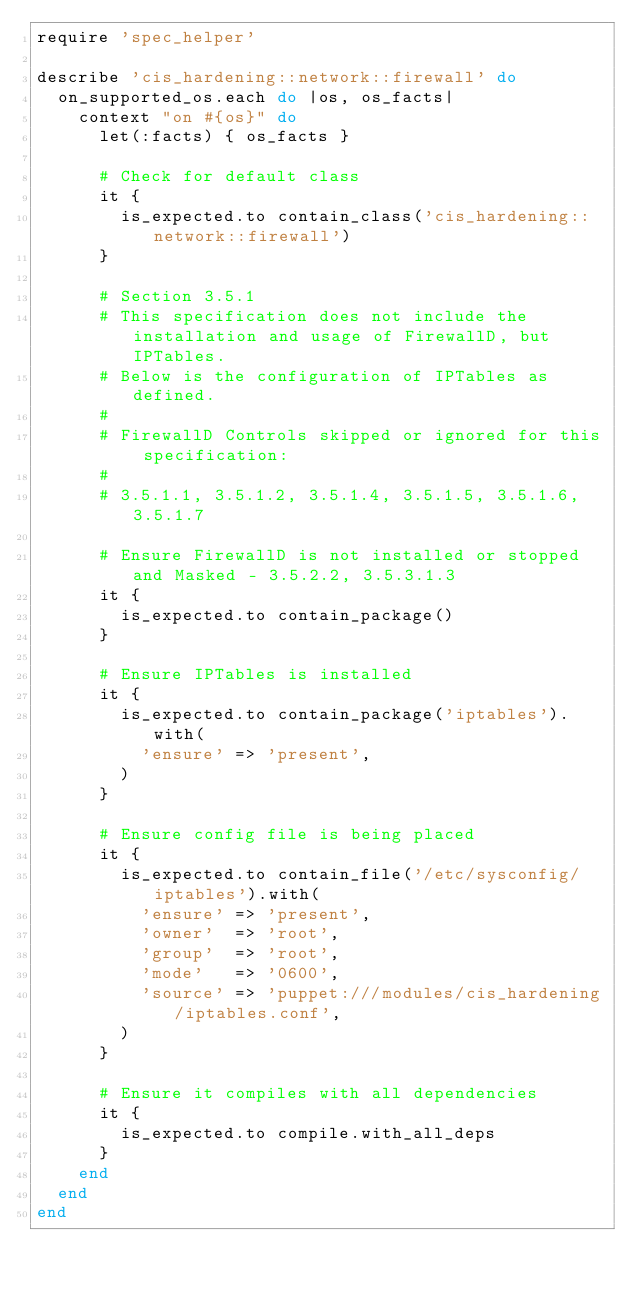Convert code to text. <code><loc_0><loc_0><loc_500><loc_500><_Ruby_>require 'spec_helper'

describe 'cis_hardening::network::firewall' do
  on_supported_os.each do |os, os_facts|
    context "on #{os}" do
      let(:facts) { os_facts }

      # Check for default class
      it {
        is_expected.to contain_class('cis_hardening::network::firewall')
      }

      # Section 3.5.1
      # This specification does not include the installation and usage of FirewallD, but IPTables.
      # Below is the configuration of IPTables as defined.
      #
      # FirewallD Controls skipped or ignored for this specification:
      #
      # 3.5.1.1, 3.5.1.2, 3.5.1.4, 3.5.1.5, 3.5.1.6, 3.5.1.7

      # Ensure FirewallD is not installed or stopped and Masked - 3.5.2.2, 3.5.3.1.3
      it {
        is_expected.to contain_package()
      }

      # Ensure IPTables is installed
      it {
        is_expected.to contain_package('iptables').with(
          'ensure' => 'present',
        )
      }

      # Ensure config file is being placed
      it {
        is_expected.to contain_file('/etc/sysconfig/iptables').with(
          'ensure' => 'present',
          'owner'  => 'root',
          'group'  => 'root',
          'mode'   => '0600',
          'source' => 'puppet:///modules/cis_hardening/iptables.conf',
        )
      }

      # Ensure it compiles with all dependencies
      it {
        is_expected.to compile.with_all_deps
      }
    end
  end
end
</code> 